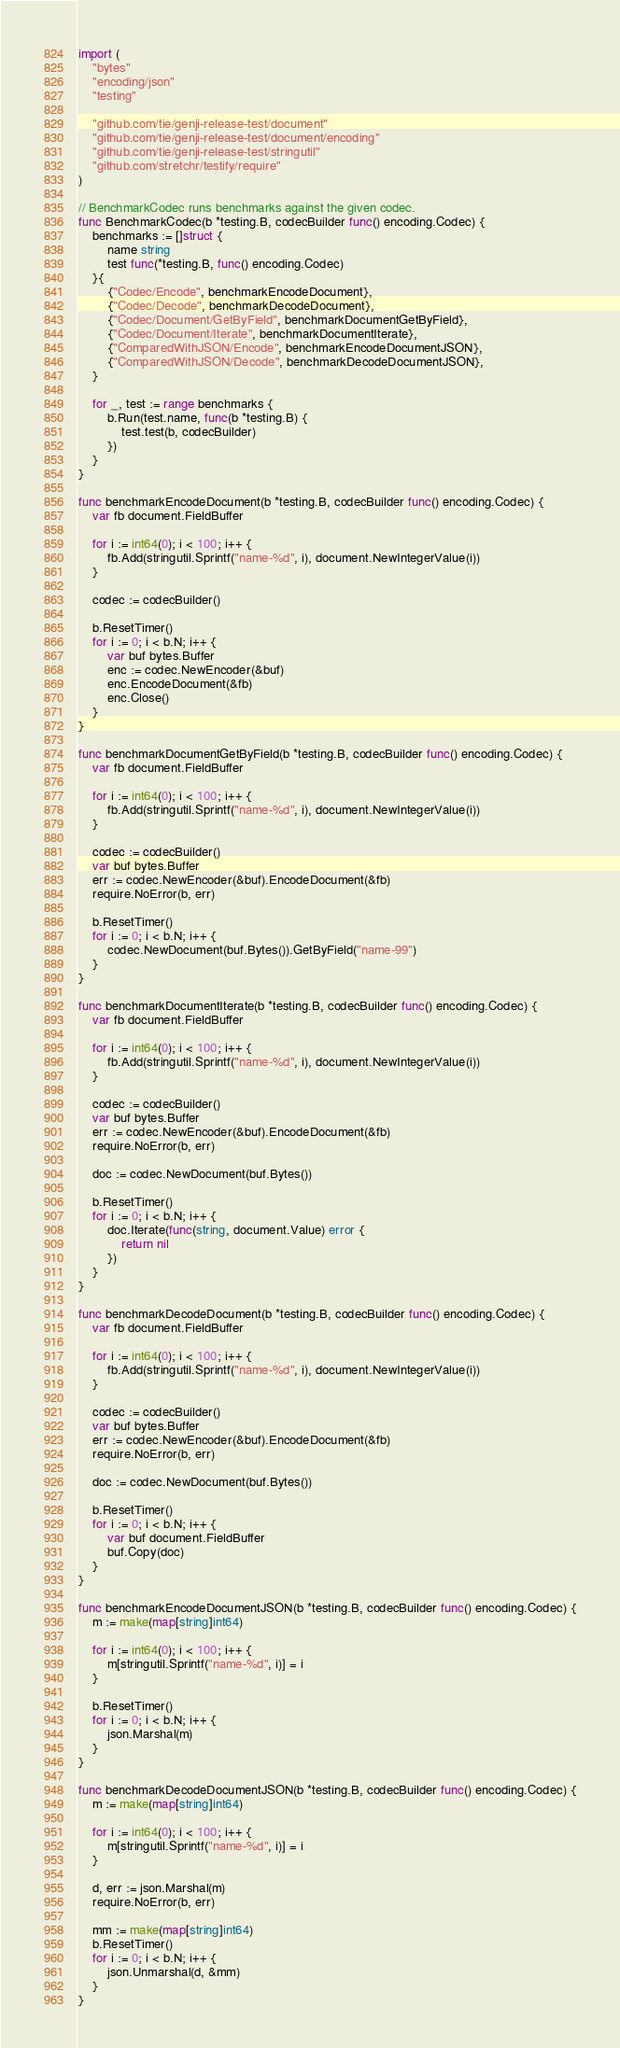Convert code to text. <code><loc_0><loc_0><loc_500><loc_500><_Go_>
import (
	"bytes"
	"encoding/json"
	"testing"

	"github.com/tie/genji-release-test/document"
	"github.com/tie/genji-release-test/document/encoding"
	"github.com/tie/genji-release-test/stringutil"
	"github.com/stretchr/testify/require"
)

// BenchmarkCodec runs benchmarks against the given codec.
func BenchmarkCodec(b *testing.B, codecBuilder func() encoding.Codec) {
	benchmarks := []struct {
		name string
		test func(*testing.B, func() encoding.Codec)
	}{
		{"Codec/Encode", benchmarkEncodeDocument},
		{"Codec/Decode", benchmarkDecodeDocument},
		{"Codec/Document/GetByField", benchmarkDocumentGetByField},
		{"Codec/Document/Iterate", benchmarkDocumentIterate},
		{"ComparedWithJSON/Encode", benchmarkEncodeDocumentJSON},
		{"ComparedWithJSON/Decode", benchmarkDecodeDocumentJSON},
	}

	for _, test := range benchmarks {
		b.Run(test.name, func(b *testing.B) {
			test.test(b, codecBuilder)
		})
	}
}

func benchmarkEncodeDocument(b *testing.B, codecBuilder func() encoding.Codec) {
	var fb document.FieldBuffer

	for i := int64(0); i < 100; i++ {
		fb.Add(stringutil.Sprintf("name-%d", i), document.NewIntegerValue(i))
	}

	codec := codecBuilder()

	b.ResetTimer()
	for i := 0; i < b.N; i++ {
		var buf bytes.Buffer
		enc := codec.NewEncoder(&buf)
		enc.EncodeDocument(&fb)
		enc.Close()
	}
}

func benchmarkDocumentGetByField(b *testing.B, codecBuilder func() encoding.Codec) {
	var fb document.FieldBuffer

	for i := int64(0); i < 100; i++ {
		fb.Add(stringutil.Sprintf("name-%d", i), document.NewIntegerValue(i))
	}

	codec := codecBuilder()
	var buf bytes.Buffer
	err := codec.NewEncoder(&buf).EncodeDocument(&fb)
	require.NoError(b, err)

	b.ResetTimer()
	for i := 0; i < b.N; i++ {
		codec.NewDocument(buf.Bytes()).GetByField("name-99")
	}
}

func benchmarkDocumentIterate(b *testing.B, codecBuilder func() encoding.Codec) {
	var fb document.FieldBuffer

	for i := int64(0); i < 100; i++ {
		fb.Add(stringutil.Sprintf("name-%d", i), document.NewIntegerValue(i))
	}

	codec := codecBuilder()
	var buf bytes.Buffer
	err := codec.NewEncoder(&buf).EncodeDocument(&fb)
	require.NoError(b, err)

	doc := codec.NewDocument(buf.Bytes())

	b.ResetTimer()
	for i := 0; i < b.N; i++ {
		doc.Iterate(func(string, document.Value) error {
			return nil
		})
	}
}

func benchmarkDecodeDocument(b *testing.B, codecBuilder func() encoding.Codec) {
	var fb document.FieldBuffer

	for i := int64(0); i < 100; i++ {
		fb.Add(stringutil.Sprintf("name-%d", i), document.NewIntegerValue(i))
	}

	codec := codecBuilder()
	var buf bytes.Buffer
	err := codec.NewEncoder(&buf).EncodeDocument(&fb)
	require.NoError(b, err)

	doc := codec.NewDocument(buf.Bytes())

	b.ResetTimer()
	for i := 0; i < b.N; i++ {
		var buf document.FieldBuffer
		buf.Copy(doc)
	}
}

func benchmarkEncodeDocumentJSON(b *testing.B, codecBuilder func() encoding.Codec) {
	m := make(map[string]int64)

	for i := int64(0); i < 100; i++ {
		m[stringutil.Sprintf("name-%d", i)] = i
	}

	b.ResetTimer()
	for i := 0; i < b.N; i++ {
		json.Marshal(m)
	}
}

func benchmarkDecodeDocumentJSON(b *testing.B, codecBuilder func() encoding.Codec) {
	m := make(map[string]int64)

	for i := int64(0); i < 100; i++ {
		m[stringutil.Sprintf("name-%d", i)] = i
	}

	d, err := json.Marshal(m)
	require.NoError(b, err)

	mm := make(map[string]int64)
	b.ResetTimer()
	for i := 0; i < b.N; i++ {
		json.Unmarshal(d, &mm)
	}
}
</code> 